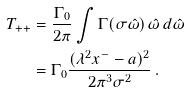<formula> <loc_0><loc_0><loc_500><loc_500>T _ { + + } & = \frac { \Gamma _ { 0 } } { 2 \pi } \int \Gamma ( \sigma \hat { \omega } ) \, \hat { \omega } \, d \hat { \omega } \\ & = \Gamma _ { 0 } \frac { ( \lambda ^ { 2 } x ^ { - } - a ) ^ { 2 } } { 2 \pi ^ { 3 } \sigma ^ { 2 } } \, .</formula> 